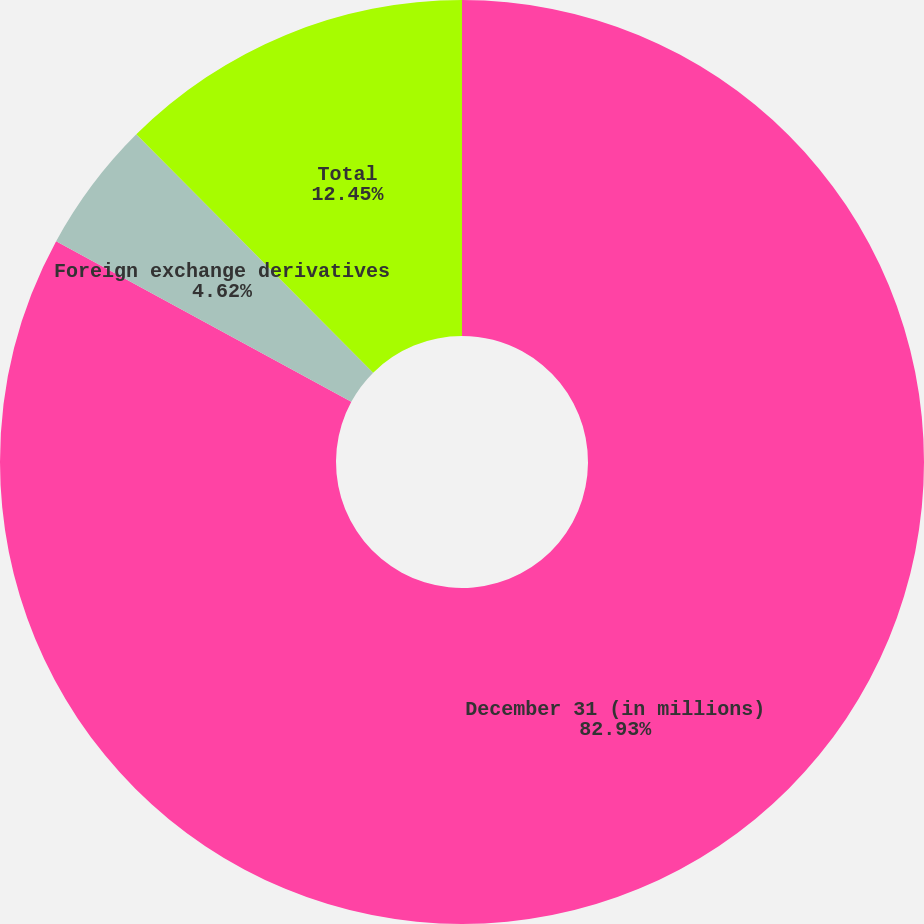<chart> <loc_0><loc_0><loc_500><loc_500><pie_chart><fcel>December 31 (in millions)<fcel>Foreign exchange derivatives<fcel>Total<nl><fcel>82.92%<fcel>4.62%<fcel>12.45%<nl></chart> 